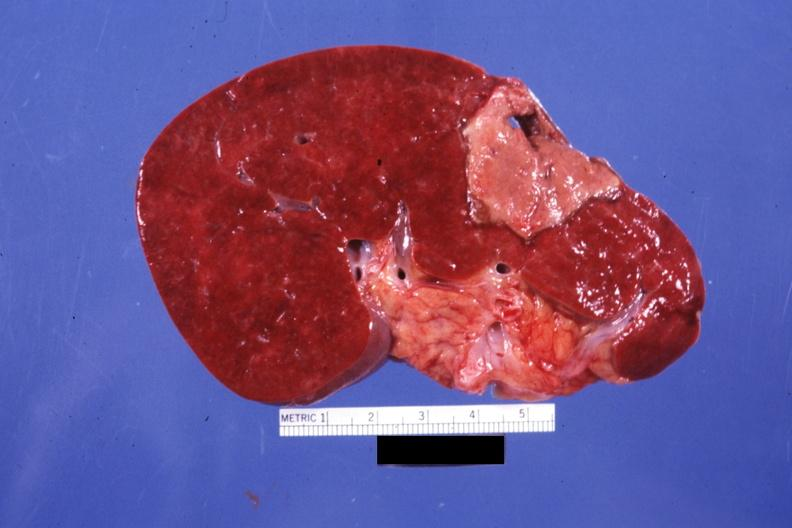s granulomata slide present?
Answer the question using a single word or phrase. No 